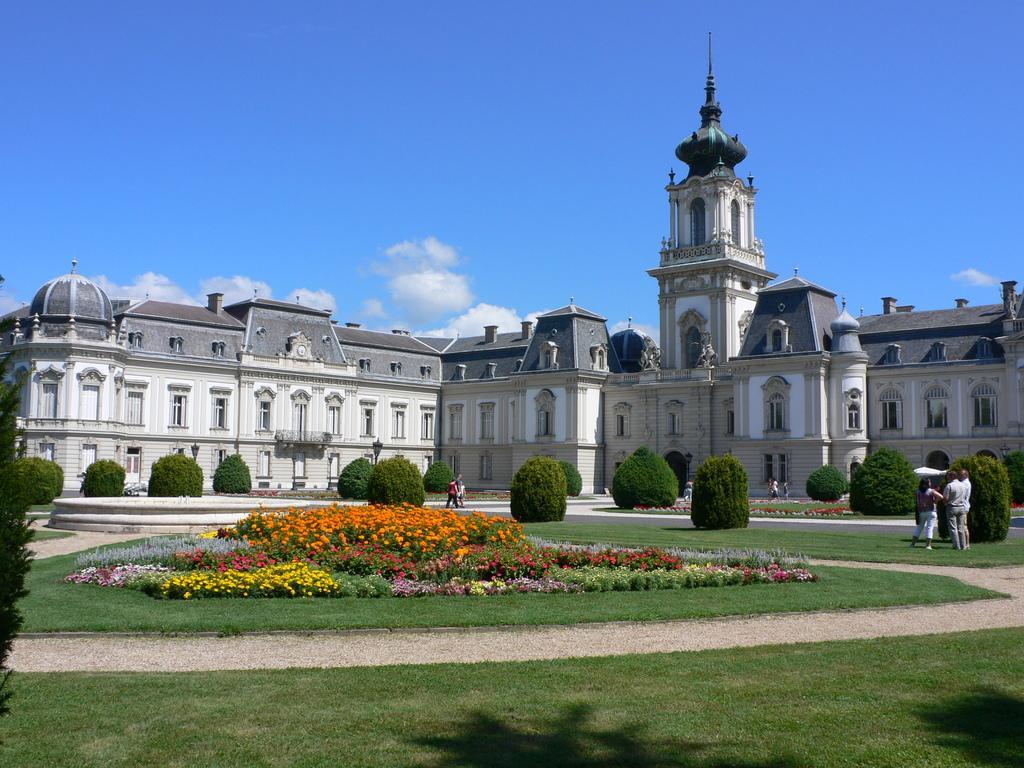Describe this image in one or two sentences. In the center of the image we can see the sky, clouds, one building, windows, trees, plants, flowers, grass and a few people. 